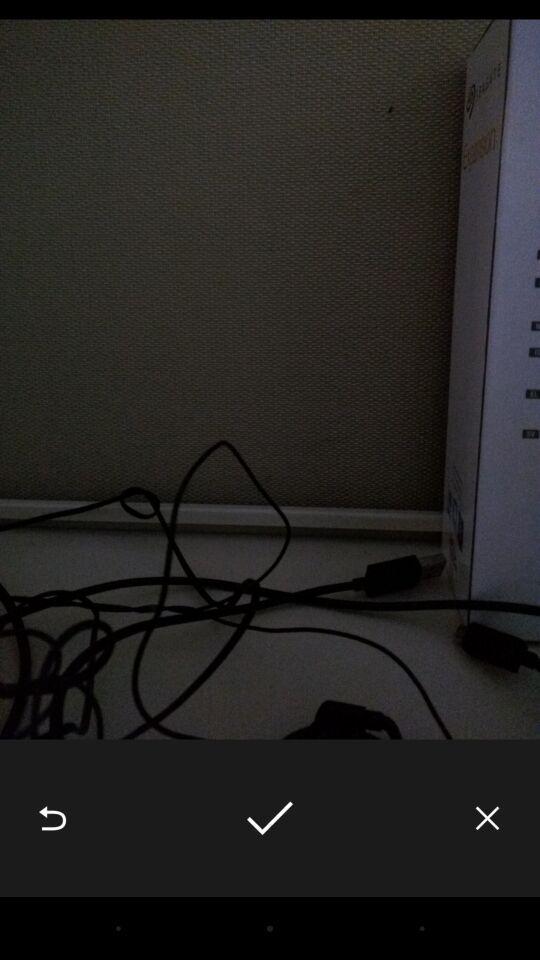Give me a narrative description of this picture. Screen displaying image of a wire. 